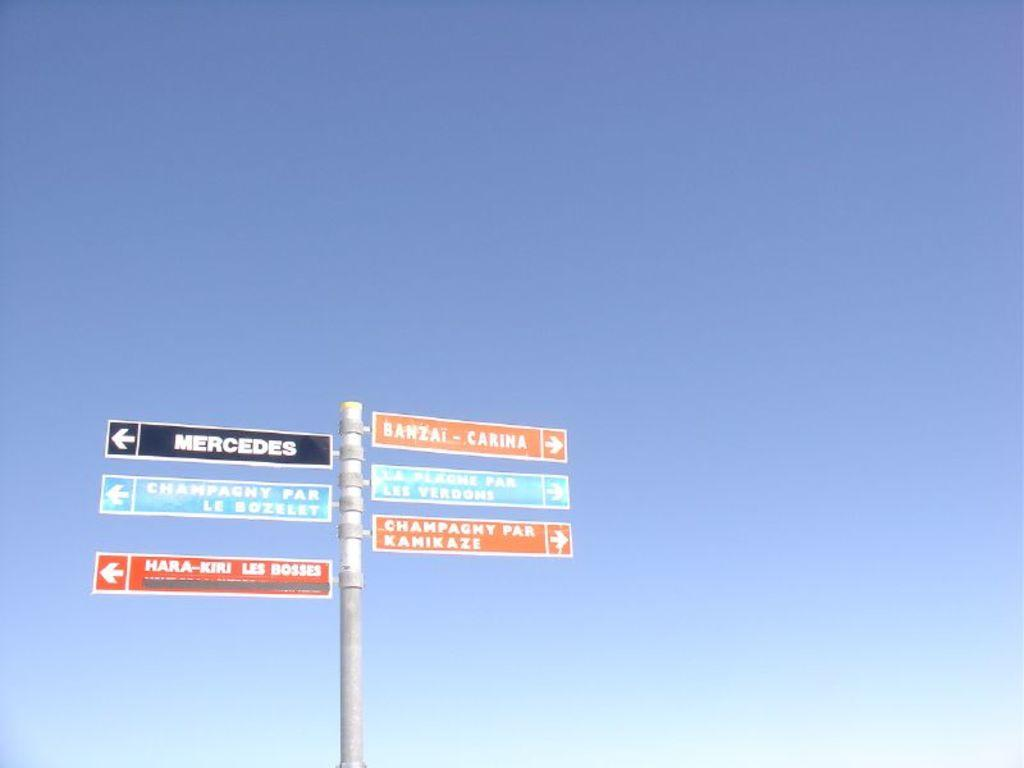Provide a one-sentence caption for the provided image. Six signs on a post, one pointing to Mercedes. 